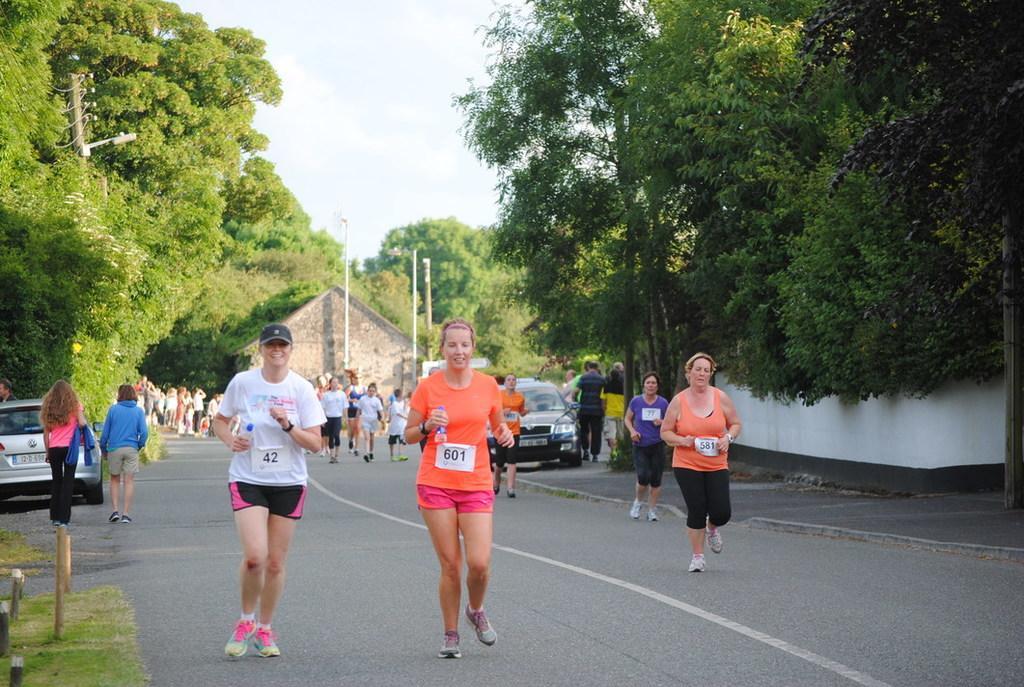How would you summarize this image in a sentence or two? In this picture we can see a few people are running and some people are walking on the road. There are a few people standing on the road. We can see the poles on the grass on the left side. There are vehicles and trees visible on the right and left side of the image. We can see a pole on the left side. There is a house visible in the background. 